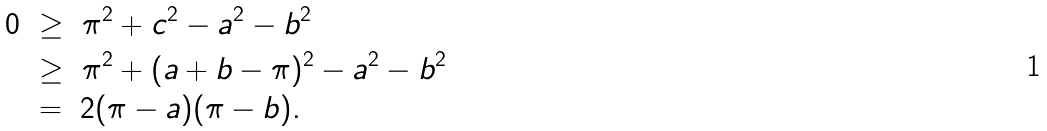Convert formula to latex. <formula><loc_0><loc_0><loc_500><loc_500>0 & \ \geq \ \pi ^ { 2 } + c ^ { 2 } - a ^ { 2 } - b ^ { 2 } \\ & \ \geq \ \pi ^ { 2 } + ( a + b - \pi ) ^ { 2 } - a ^ { 2 } - b ^ { 2 } \\ & \ = \ 2 ( \pi - a ) ( \pi - b ) .</formula> 